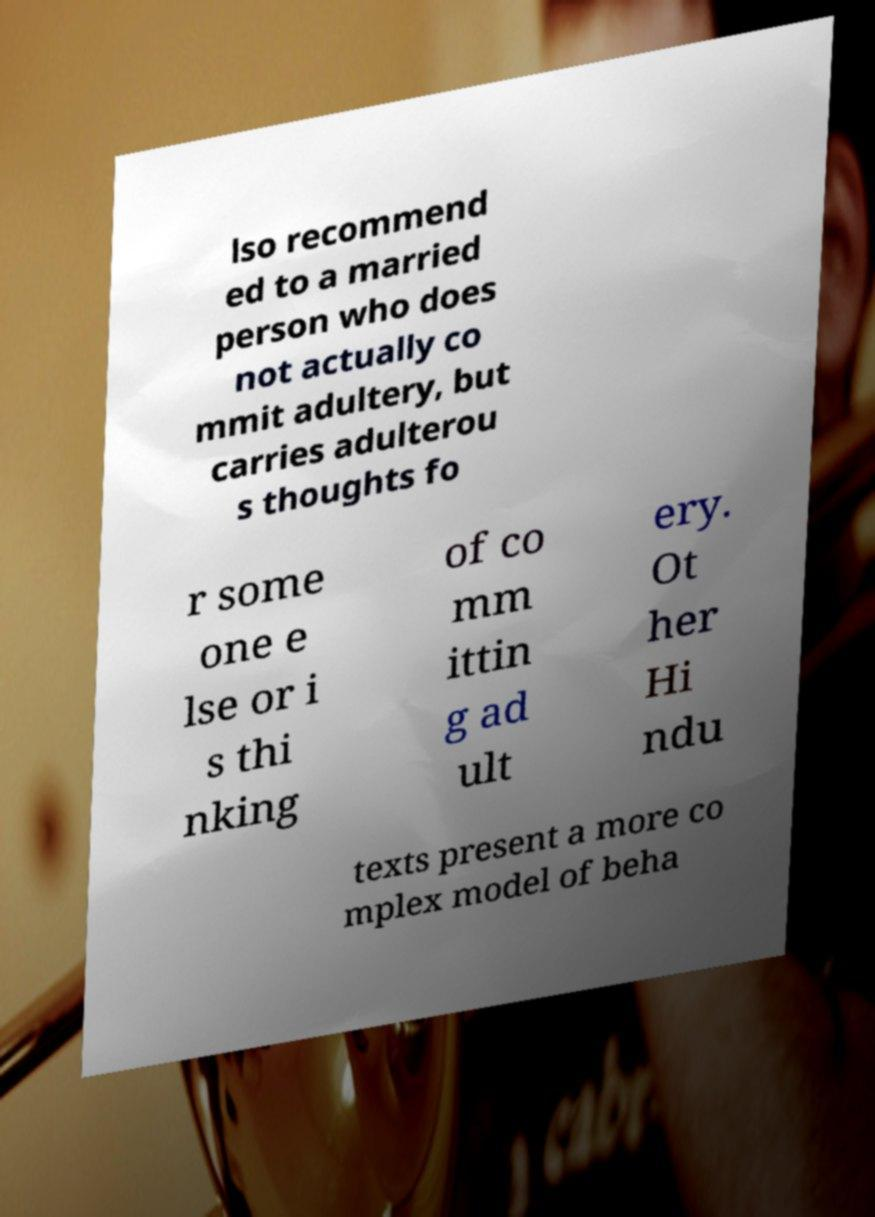Please read and relay the text visible in this image. What does it say? lso recommend ed to a married person who does not actually co mmit adultery, but carries adulterou s thoughts fo r some one e lse or i s thi nking of co mm ittin g ad ult ery. Ot her Hi ndu texts present a more co mplex model of beha 